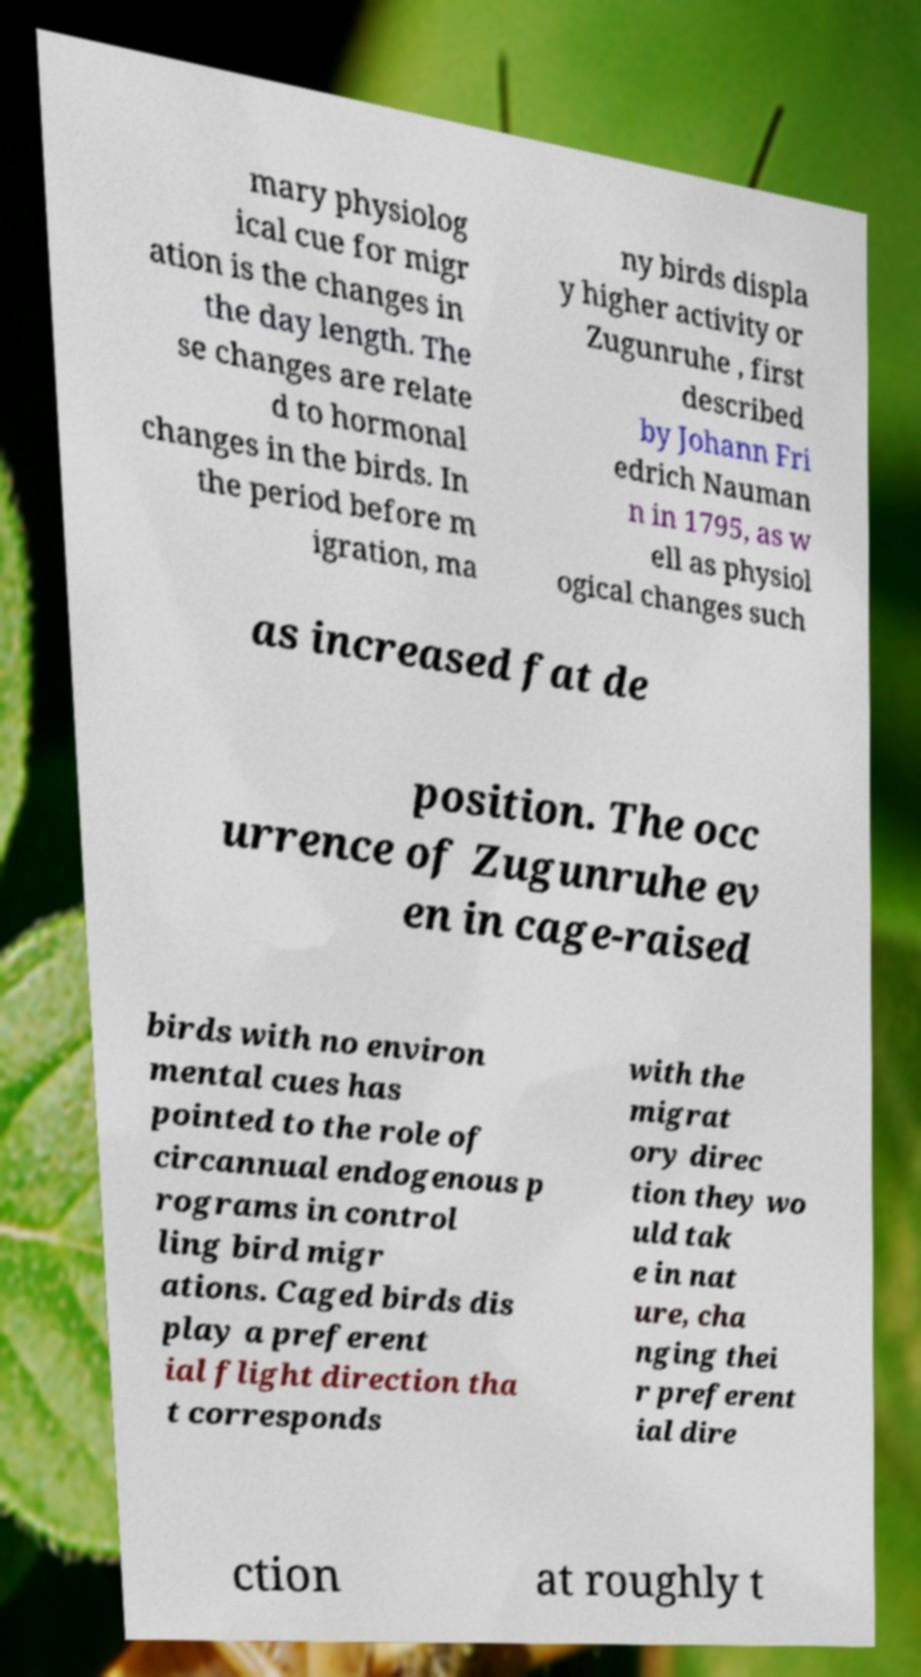Can you read and provide the text displayed in the image?This photo seems to have some interesting text. Can you extract and type it out for me? mary physiolog ical cue for migr ation is the changes in the day length. The se changes are relate d to hormonal changes in the birds. In the period before m igration, ma ny birds displa y higher activity or Zugunruhe , first described by Johann Fri edrich Nauman n in 1795, as w ell as physiol ogical changes such as increased fat de position. The occ urrence of Zugunruhe ev en in cage-raised birds with no environ mental cues has pointed to the role of circannual endogenous p rograms in control ling bird migr ations. Caged birds dis play a preferent ial flight direction tha t corresponds with the migrat ory direc tion they wo uld tak e in nat ure, cha nging thei r preferent ial dire ction at roughly t 